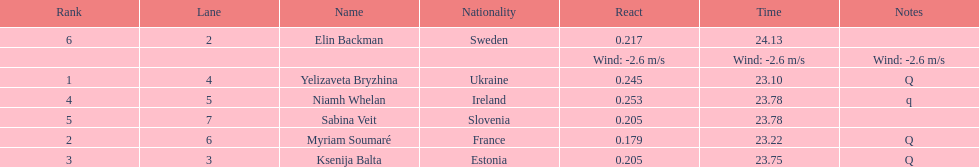How long did it take elin backman to finish the race? 24.13. 